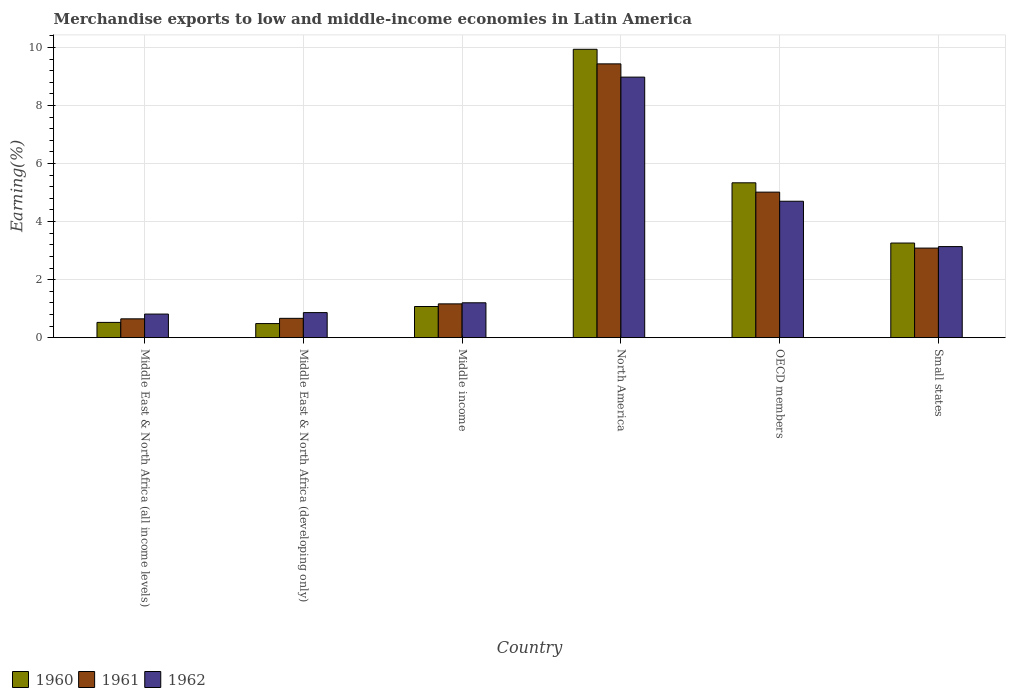How many groups of bars are there?
Your answer should be compact. 6. Are the number of bars per tick equal to the number of legend labels?
Ensure brevity in your answer.  Yes. What is the label of the 6th group of bars from the left?
Make the answer very short. Small states. In how many cases, is the number of bars for a given country not equal to the number of legend labels?
Your answer should be very brief. 0. What is the percentage of amount earned from merchandise exports in 1962 in Middle East & North Africa (all income levels)?
Make the answer very short. 0.81. Across all countries, what is the maximum percentage of amount earned from merchandise exports in 1960?
Offer a terse response. 9.94. Across all countries, what is the minimum percentage of amount earned from merchandise exports in 1961?
Ensure brevity in your answer.  0.65. In which country was the percentage of amount earned from merchandise exports in 1961 minimum?
Your answer should be very brief. Middle East & North Africa (all income levels). What is the total percentage of amount earned from merchandise exports in 1962 in the graph?
Make the answer very short. 19.7. What is the difference between the percentage of amount earned from merchandise exports in 1962 in Middle income and that in North America?
Provide a short and direct response. -7.78. What is the difference between the percentage of amount earned from merchandise exports in 1961 in North America and the percentage of amount earned from merchandise exports in 1962 in Middle East & North Africa (developing only)?
Provide a short and direct response. 8.57. What is the average percentage of amount earned from merchandise exports in 1961 per country?
Keep it short and to the point. 3.34. What is the difference between the percentage of amount earned from merchandise exports of/in 1961 and percentage of amount earned from merchandise exports of/in 1960 in Middle East & North Africa (all income levels)?
Make the answer very short. 0.12. What is the ratio of the percentage of amount earned from merchandise exports in 1960 in North America to that in OECD members?
Your answer should be compact. 1.86. Is the difference between the percentage of amount earned from merchandise exports in 1961 in Middle East & North Africa (all income levels) and Small states greater than the difference between the percentage of amount earned from merchandise exports in 1960 in Middle East & North Africa (all income levels) and Small states?
Your response must be concise. Yes. What is the difference between the highest and the second highest percentage of amount earned from merchandise exports in 1960?
Provide a short and direct response. 6.68. What is the difference between the highest and the lowest percentage of amount earned from merchandise exports in 1962?
Offer a very short reply. 8.17. In how many countries, is the percentage of amount earned from merchandise exports in 1960 greater than the average percentage of amount earned from merchandise exports in 1960 taken over all countries?
Ensure brevity in your answer.  2. Is the sum of the percentage of amount earned from merchandise exports in 1960 in North America and OECD members greater than the maximum percentage of amount earned from merchandise exports in 1961 across all countries?
Offer a terse response. Yes. Is it the case that in every country, the sum of the percentage of amount earned from merchandise exports in 1960 and percentage of amount earned from merchandise exports in 1961 is greater than the percentage of amount earned from merchandise exports in 1962?
Offer a terse response. Yes. How many bars are there?
Give a very brief answer. 18. How many countries are there in the graph?
Provide a short and direct response. 6. Does the graph contain any zero values?
Give a very brief answer. No. Does the graph contain grids?
Offer a terse response. Yes. Where does the legend appear in the graph?
Your answer should be compact. Bottom left. How many legend labels are there?
Ensure brevity in your answer.  3. What is the title of the graph?
Your response must be concise. Merchandise exports to low and middle-income economies in Latin America. What is the label or title of the X-axis?
Offer a very short reply. Country. What is the label or title of the Y-axis?
Provide a succinct answer. Earning(%). What is the Earning(%) in 1960 in Middle East & North Africa (all income levels)?
Offer a terse response. 0.53. What is the Earning(%) of 1961 in Middle East & North Africa (all income levels)?
Your response must be concise. 0.65. What is the Earning(%) of 1962 in Middle East & North Africa (all income levels)?
Your answer should be very brief. 0.81. What is the Earning(%) of 1960 in Middle East & North Africa (developing only)?
Your response must be concise. 0.49. What is the Earning(%) in 1961 in Middle East & North Africa (developing only)?
Your answer should be compact. 0.67. What is the Earning(%) in 1962 in Middle East & North Africa (developing only)?
Offer a terse response. 0.86. What is the Earning(%) of 1960 in Middle income?
Your answer should be compact. 1.07. What is the Earning(%) of 1961 in Middle income?
Make the answer very short. 1.16. What is the Earning(%) in 1962 in Middle income?
Your answer should be compact. 1.2. What is the Earning(%) of 1960 in North America?
Provide a short and direct response. 9.94. What is the Earning(%) of 1961 in North America?
Your answer should be very brief. 9.44. What is the Earning(%) in 1962 in North America?
Your answer should be very brief. 8.98. What is the Earning(%) of 1960 in OECD members?
Provide a succinct answer. 5.34. What is the Earning(%) of 1961 in OECD members?
Provide a succinct answer. 5.02. What is the Earning(%) of 1962 in OECD members?
Your answer should be compact. 4.7. What is the Earning(%) in 1960 in Small states?
Your answer should be compact. 3.26. What is the Earning(%) of 1961 in Small states?
Provide a short and direct response. 3.09. What is the Earning(%) in 1962 in Small states?
Your answer should be very brief. 3.14. Across all countries, what is the maximum Earning(%) in 1960?
Offer a very short reply. 9.94. Across all countries, what is the maximum Earning(%) of 1961?
Offer a terse response. 9.44. Across all countries, what is the maximum Earning(%) of 1962?
Your response must be concise. 8.98. Across all countries, what is the minimum Earning(%) in 1960?
Make the answer very short. 0.49. Across all countries, what is the minimum Earning(%) of 1961?
Your answer should be very brief. 0.65. Across all countries, what is the minimum Earning(%) in 1962?
Provide a short and direct response. 0.81. What is the total Earning(%) of 1960 in the graph?
Keep it short and to the point. 20.62. What is the total Earning(%) in 1961 in the graph?
Your answer should be compact. 20.02. What is the total Earning(%) of 1962 in the graph?
Your answer should be compact. 19.7. What is the difference between the Earning(%) of 1960 in Middle East & North Africa (all income levels) and that in Middle East & North Africa (developing only)?
Give a very brief answer. 0.04. What is the difference between the Earning(%) in 1961 in Middle East & North Africa (all income levels) and that in Middle East & North Africa (developing only)?
Your answer should be very brief. -0.02. What is the difference between the Earning(%) of 1962 in Middle East & North Africa (all income levels) and that in Middle East & North Africa (developing only)?
Offer a terse response. -0.05. What is the difference between the Earning(%) in 1960 in Middle East & North Africa (all income levels) and that in Middle income?
Provide a short and direct response. -0.55. What is the difference between the Earning(%) in 1961 in Middle East & North Africa (all income levels) and that in Middle income?
Ensure brevity in your answer.  -0.52. What is the difference between the Earning(%) of 1962 in Middle East & North Africa (all income levels) and that in Middle income?
Give a very brief answer. -0.39. What is the difference between the Earning(%) of 1960 in Middle East & North Africa (all income levels) and that in North America?
Your answer should be compact. -9.41. What is the difference between the Earning(%) of 1961 in Middle East & North Africa (all income levels) and that in North America?
Give a very brief answer. -8.79. What is the difference between the Earning(%) in 1962 in Middle East & North Africa (all income levels) and that in North America?
Provide a short and direct response. -8.17. What is the difference between the Earning(%) of 1960 in Middle East & North Africa (all income levels) and that in OECD members?
Provide a succinct answer. -4.81. What is the difference between the Earning(%) of 1961 in Middle East & North Africa (all income levels) and that in OECD members?
Offer a very short reply. -4.37. What is the difference between the Earning(%) of 1962 in Middle East & North Africa (all income levels) and that in OECD members?
Make the answer very short. -3.89. What is the difference between the Earning(%) in 1960 in Middle East & North Africa (all income levels) and that in Small states?
Your response must be concise. -2.73. What is the difference between the Earning(%) of 1961 in Middle East & North Africa (all income levels) and that in Small states?
Your answer should be compact. -2.44. What is the difference between the Earning(%) in 1962 in Middle East & North Africa (all income levels) and that in Small states?
Your answer should be compact. -2.33. What is the difference between the Earning(%) of 1960 in Middle East & North Africa (developing only) and that in Middle income?
Make the answer very short. -0.59. What is the difference between the Earning(%) of 1961 in Middle East & North Africa (developing only) and that in Middle income?
Offer a terse response. -0.5. What is the difference between the Earning(%) of 1962 in Middle East & North Africa (developing only) and that in Middle income?
Ensure brevity in your answer.  -0.34. What is the difference between the Earning(%) of 1960 in Middle East & North Africa (developing only) and that in North America?
Make the answer very short. -9.45. What is the difference between the Earning(%) in 1961 in Middle East & North Africa (developing only) and that in North America?
Provide a short and direct response. -8.77. What is the difference between the Earning(%) of 1962 in Middle East & North Africa (developing only) and that in North America?
Offer a very short reply. -8.12. What is the difference between the Earning(%) in 1960 in Middle East & North Africa (developing only) and that in OECD members?
Make the answer very short. -4.85. What is the difference between the Earning(%) of 1961 in Middle East & North Africa (developing only) and that in OECD members?
Make the answer very short. -4.35. What is the difference between the Earning(%) in 1962 in Middle East & North Africa (developing only) and that in OECD members?
Provide a short and direct response. -3.84. What is the difference between the Earning(%) of 1960 in Middle East & North Africa (developing only) and that in Small states?
Make the answer very short. -2.77. What is the difference between the Earning(%) of 1961 in Middle East & North Africa (developing only) and that in Small states?
Your answer should be compact. -2.42. What is the difference between the Earning(%) of 1962 in Middle East & North Africa (developing only) and that in Small states?
Your answer should be very brief. -2.28. What is the difference between the Earning(%) of 1960 in Middle income and that in North America?
Keep it short and to the point. -8.86. What is the difference between the Earning(%) of 1961 in Middle income and that in North America?
Ensure brevity in your answer.  -8.27. What is the difference between the Earning(%) of 1962 in Middle income and that in North America?
Give a very brief answer. -7.78. What is the difference between the Earning(%) in 1960 in Middle income and that in OECD members?
Offer a terse response. -4.26. What is the difference between the Earning(%) of 1961 in Middle income and that in OECD members?
Your answer should be very brief. -3.85. What is the difference between the Earning(%) in 1962 in Middle income and that in OECD members?
Offer a terse response. -3.5. What is the difference between the Earning(%) in 1960 in Middle income and that in Small states?
Offer a terse response. -2.19. What is the difference between the Earning(%) in 1961 in Middle income and that in Small states?
Make the answer very short. -1.92. What is the difference between the Earning(%) of 1962 in Middle income and that in Small states?
Keep it short and to the point. -1.94. What is the difference between the Earning(%) in 1960 in North America and that in OECD members?
Keep it short and to the point. 4.6. What is the difference between the Earning(%) in 1961 in North America and that in OECD members?
Offer a terse response. 4.42. What is the difference between the Earning(%) in 1962 in North America and that in OECD members?
Offer a terse response. 4.28. What is the difference between the Earning(%) in 1960 in North America and that in Small states?
Offer a terse response. 6.68. What is the difference between the Earning(%) of 1961 in North America and that in Small states?
Make the answer very short. 6.35. What is the difference between the Earning(%) of 1962 in North America and that in Small states?
Keep it short and to the point. 5.84. What is the difference between the Earning(%) of 1960 in OECD members and that in Small states?
Your response must be concise. 2.08. What is the difference between the Earning(%) in 1961 in OECD members and that in Small states?
Your answer should be very brief. 1.93. What is the difference between the Earning(%) in 1962 in OECD members and that in Small states?
Offer a terse response. 1.56. What is the difference between the Earning(%) in 1960 in Middle East & North Africa (all income levels) and the Earning(%) in 1961 in Middle East & North Africa (developing only)?
Keep it short and to the point. -0.14. What is the difference between the Earning(%) of 1960 in Middle East & North Africa (all income levels) and the Earning(%) of 1962 in Middle East & North Africa (developing only)?
Provide a short and direct response. -0.34. What is the difference between the Earning(%) of 1961 in Middle East & North Africa (all income levels) and the Earning(%) of 1962 in Middle East & North Africa (developing only)?
Your answer should be compact. -0.21. What is the difference between the Earning(%) of 1960 in Middle East & North Africa (all income levels) and the Earning(%) of 1961 in Middle income?
Ensure brevity in your answer.  -0.64. What is the difference between the Earning(%) of 1960 in Middle East & North Africa (all income levels) and the Earning(%) of 1962 in Middle income?
Your answer should be very brief. -0.68. What is the difference between the Earning(%) in 1961 in Middle East & North Africa (all income levels) and the Earning(%) in 1962 in Middle income?
Your answer should be compact. -0.55. What is the difference between the Earning(%) of 1960 in Middle East & North Africa (all income levels) and the Earning(%) of 1961 in North America?
Give a very brief answer. -8.91. What is the difference between the Earning(%) of 1960 in Middle East & North Africa (all income levels) and the Earning(%) of 1962 in North America?
Make the answer very short. -8.45. What is the difference between the Earning(%) of 1961 in Middle East & North Africa (all income levels) and the Earning(%) of 1962 in North America?
Give a very brief answer. -8.33. What is the difference between the Earning(%) of 1960 in Middle East & North Africa (all income levels) and the Earning(%) of 1961 in OECD members?
Your answer should be very brief. -4.49. What is the difference between the Earning(%) in 1960 in Middle East & North Africa (all income levels) and the Earning(%) in 1962 in OECD members?
Offer a very short reply. -4.18. What is the difference between the Earning(%) of 1961 in Middle East & North Africa (all income levels) and the Earning(%) of 1962 in OECD members?
Make the answer very short. -4.05. What is the difference between the Earning(%) in 1960 in Middle East & North Africa (all income levels) and the Earning(%) in 1961 in Small states?
Offer a terse response. -2.56. What is the difference between the Earning(%) in 1960 in Middle East & North Africa (all income levels) and the Earning(%) in 1962 in Small states?
Your response must be concise. -2.61. What is the difference between the Earning(%) in 1961 in Middle East & North Africa (all income levels) and the Earning(%) in 1962 in Small states?
Give a very brief answer. -2.49. What is the difference between the Earning(%) of 1960 in Middle East & North Africa (developing only) and the Earning(%) of 1961 in Middle income?
Provide a succinct answer. -0.68. What is the difference between the Earning(%) in 1960 in Middle East & North Africa (developing only) and the Earning(%) in 1962 in Middle income?
Ensure brevity in your answer.  -0.72. What is the difference between the Earning(%) of 1961 in Middle East & North Africa (developing only) and the Earning(%) of 1962 in Middle income?
Make the answer very short. -0.54. What is the difference between the Earning(%) in 1960 in Middle East & North Africa (developing only) and the Earning(%) in 1961 in North America?
Offer a very short reply. -8.95. What is the difference between the Earning(%) of 1960 in Middle East & North Africa (developing only) and the Earning(%) of 1962 in North America?
Keep it short and to the point. -8.49. What is the difference between the Earning(%) in 1961 in Middle East & North Africa (developing only) and the Earning(%) in 1962 in North America?
Your answer should be very brief. -8.31. What is the difference between the Earning(%) in 1960 in Middle East & North Africa (developing only) and the Earning(%) in 1961 in OECD members?
Provide a succinct answer. -4.53. What is the difference between the Earning(%) of 1960 in Middle East & North Africa (developing only) and the Earning(%) of 1962 in OECD members?
Keep it short and to the point. -4.22. What is the difference between the Earning(%) of 1961 in Middle East & North Africa (developing only) and the Earning(%) of 1962 in OECD members?
Provide a short and direct response. -4.04. What is the difference between the Earning(%) of 1960 in Middle East & North Africa (developing only) and the Earning(%) of 1961 in Small states?
Your answer should be very brief. -2.6. What is the difference between the Earning(%) in 1960 in Middle East & North Africa (developing only) and the Earning(%) in 1962 in Small states?
Your answer should be compact. -2.65. What is the difference between the Earning(%) of 1961 in Middle East & North Africa (developing only) and the Earning(%) of 1962 in Small states?
Make the answer very short. -2.47. What is the difference between the Earning(%) of 1960 in Middle income and the Earning(%) of 1961 in North America?
Offer a terse response. -8.36. What is the difference between the Earning(%) in 1960 in Middle income and the Earning(%) in 1962 in North America?
Offer a very short reply. -7.91. What is the difference between the Earning(%) in 1961 in Middle income and the Earning(%) in 1962 in North America?
Your answer should be very brief. -7.81. What is the difference between the Earning(%) in 1960 in Middle income and the Earning(%) in 1961 in OECD members?
Keep it short and to the point. -3.94. What is the difference between the Earning(%) in 1960 in Middle income and the Earning(%) in 1962 in OECD members?
Your answer should be very brief. -3.63. What is the difference between the Earning(%) in 1961 in Middle income and the Earning(%) in 1962 in OECD members?
Provide a succinct answer. -3.54. What is the difference between the Earning(%) of 1960 in Middle income and the Earning(%) of 1961 in Small states?
Offer a very short reply. -2.01. What is the difference between the Earning(%) of 1960 in Middle income and the Earning(%) of 1962 in Small states?
Provide a succinct answer. -2.06. What is the difference between the Earning(%) in 1961 in Middle income and the Earning(%) in 1962 in Small states?
Provide a short and direct response. -1.97. What is the difference between the Earning(%) in 1960 in North America and the Earning(%) in 1961 in OECD members?
Make the answer very short. 4.92. What is the difference between the Earning(%) of 1960 in North America and the Earning(%) of 1962 in OECD members?
Offer a very short reply. 5.24. What is the difference between the Earning(%) in 1961 in North America and the Earning(%) in 1962 in OECD members?
Your answer should be compact. 4.73. What is the difference between the Earning(%) of 1960 in North America and the Earning(%) of 1961 in Small states?
Your answer should be compact. 6.85. What is the difference between the Earning(%) of 1960 in North America and the Earning(%) of 1962 in Small states?
Your answer should be very brief. 6.8. What is the difference between the Earning(%) in 1961 in North America and the Earning(%) in 1962 in Small states?
Your response must be concise. 6.3. What is the difference between the Earning(%) in 1960 in OECD members and the Earning(%) in 1961 in Small states?
Give a very brief answer. 2.25. What is the difference between the Earning(%) of 1960 in OECD members and the Earning(%) of 1962 in Small states?
Ensure brevity in your answer.  2.2. What is the difference between the Earning(%) of 1961 in OECD members and the Earning(%) of 1962 in Small states?
Give a very brief answer. 1.88. What is the average Earning(%) in 1960 per country?
Make the answer very short. 3.44. What is the average Earning(%) in 1961 per country?
Give a very brief answer. 3.34. What is the average Earning(%) of 1962 per country?
Ensure brevity in your answer.  3.28. What is the difference between the Earning(%) in 1960 and Earning(%) in 1961 in Middle East & North Africa (all income levels)?
Make the answer very short. -0.12. What is the difference between the Earning(%) in 1960 and Earning(%) in 1962 in Middle East & North Africa (all income levels)?
Ensure brevity in your answer.  -0.29. What is the difference between the Earning(%) of 1961 and Earning(%) of 1962 in Middle East & North Africa (all income levels)?
Keep it short and to the point. -0.16. What is the difference between the Earning(%) in 1960 and Earning(%) in 1961 in Middle East & North Africa (developing only)?
Your answer should be compact. -0.18. What is the difference between the Earning(%) of 1960 and Earning(%) of 1962 in Middle East & North Africa (developing only)?
Your answer should be compact. -0.38. What is the difference between the Earning(%) of 1961 and Earning(%) of 1962 in Middle East & North Africa (developing only)?
Offer a terse response. -0.2. What is the difference between the Earning(%) in 1960 and Earning(%) in 1961 in Middle income?
Offer a very short reply. -0.09. What is the difference between the Earning(%) of 1960 and Earning(%) of 1962 in Middle income?
Provide a succinct answer. -0.13. What is the difference between the Earning(%) of 1961 and Earning(%) of 1962 in Middle income?
Offer a very short reply. -0.04. What is the difference between the Earning(%) of 1960 and Earning(%) of 1961 in North America?
Offer a very short reply. 0.5. What is the difference between the Earning(%) of 1960 and Earning(%) of 1962 in North America?
Provide a succinct answer. 0.96. What is the difference between the Earning(%) in 1961 and Earning(%) in 1962 in North America?
Give a very brief answer. 0.46. What is the difference between the Earning(%) in 1960 and Earning(%) in 1961 in OECD members?
Your response must be concise. 0.32. What is the difference between the Earning(%) in 1960 and Earning(%) in 1962 in OECD members?
Provide a succinct answer. 0.64. What is the difference between the Earning(%) of 1961 and Earning(%) of 1962 in OECD members?
Your answer should be compact. 0.31. What is the difference between the Earning(%) of 1960 and Earning(%) of 1961 in Small states?
Make the answer very short. 0.17. What is the difference between the Earning(%) in 1960 and Earning(%) in 1962 in Small states?
Offer a terse response. 0.12. What is the difference between the Earning(%) in 1961 and Earning(%) in 1962 in Small states?
Keep it short and to the point. -0.05. What is the ratio of the Earning(%) in 1960 in Middle East & North Africa (all income levels) to that in Middle East & North Africa (developing only)?
Offer a terse response. 1.08. What is the ratio of the Earning(%) in 1961 in Middle East & North Africa (all income levels) to that in Middle East & North Africa (developing only)?
Give a very brief answer. 0.97. What is the ratio of the Earning(%) in 1962 in Middle East & North Africa (all income levels) to that in Middle East & North Africa (developing only)?
Offer a very short reply. 0.94. What is the ratio of the Earning(%) of 1960 in Middle East & North Africa (all income levels) to that in Middle income?
Your answer should be compact. 0.49. What is the ratio of the Earning(%) in 1961 in Middle East & North Africa (all income levels) to that in Middle income?
Make the answer very short. 0.56. What is the ratio of the Earning(%) of 1962 in Middle East & North Africa (all income levels) to that in Middle income?
Provide a succinct answer. 0.68. What is the ratio of the Earning(%) in 1960 in Middle East & North Africa (all income levels) to that in North America?
Provide a short and direct response. 0.05. What is the ratio of the Earning(%) of 1961 in Middle East & North Africa (all income levels) to that in North America?
Make the answer very short. 0.07. What is the ratio of the Earning(%) of 1962 in Middle East & North Africa (all income levels) to that in North America?
Your response must be concise. 0.09. What is the ratio of the Earning(%) of 1960 in Middle East & North Africa (all income levels) to that in OECD members?
Your response must be concise. 0.1. What is the ratio of the Earning(%) of 1961 in Middle East & North Africa (all income levels) to that in OECD members?
Offer a very short reply. 0.13. What is the ratio of the Earning(%) in 1962 in Middle East & North Africa (all income levels) to that in OECD members?
Keep it short and to the point. 0.17. What is the ratio of the Earning(%) of 1960 in Middle East & North Africa (all income levels) to that in Small states?
Your answer should be very brief. 0.16. What is the ratio of the Earning(%) of 1961 in Middle East & North Africa (all income levels) to that in Small states?
Your answer should be compact. 0.21. What is the ratio of the Earning(%) of 1962 in Middle East & North Africa (all income levels) to that in Small states?
Your response must be concise. 0.26. What is the ratio of the Earning(%) in 1960 in Middle East & North Africa (developing only) to that in Middle income?
Keep it short and to the point. 0.45. What is the ratio of the Earning(%) in 1961 in Middle East & North Africa (developing only) to that in Middle income?
Your answer should be compact. 0.57. What is the ratio of the Earning(%) of 1962 in Middle East & North Africa (developing only) to that in Middle income?
Provide a short and direct response. 0.72. What is the ratio of the Earning(%) in 1960 in Middle East & North Africa (developing only) to that in North America?
Provide a succinct answer. 0.05. What is the ratio of the Earning(%) in 1961 in Middle East & North Africa (developing only) to that in North America?
Offer a very short reply. 0.07. What is the ratio of the Earning(%) in 1962 in Middle East & North Africa (developing only) to that in North America?
Offer a terse response. 0.1. What is the ratio of the Earning(%) of 1960 in Middle East & North Africa (developing only) to that in OECD members?
Offer a very short reply. 0.09. What is the ratio of the Earning(%) of 1961 in Middle East & North Africa (developing only) to that in OECD members?
Keep it short and to the point. 0.13. What is the ratio of the Earning(%) in 1962 in Middle East & North Africa (developing only) to that in OECD members?
Your answer should be very brief. 0.18. What is the ratio of the Earning(%) in 1960 in Middle East & North Africa (developing only) to that in Small states?
Offer a terse response. 0.15. What is the ratio of the Earning(%) of 1961 in Middle East & North Africa (developing only) to that in Small states?
Provide a short and direct response. 0.22. What is the ratio of the Earning(%) in 1962 in Middle East & North Africa (developing only) to that in Small states?
Provide a succinct answer. 0.28. What is the ratio of the Earning(%) in 1960 in Middle income to that in North America?
Ensure brevity in your answer.  0.11. What is the ratio of the Earning(%) of 1961 in Middle income to that in North America?
Your answer should be compact. 0.12. What is the ratio of the Earning(%) of 1962 in Middle income to that in North America?
Provide a short and direct response. 0.13. What is the ratio of the Earning(%) in 1960 in Middle income to that in OECD members?
Ensure brevity in your answer.  0.2. What is the ratio of the Earning(%) of 1961 in Middle income to that in OECD members?
Your response must be concise. 0.23. What is the ratio of the Earning(%) in 1962 in Middle income to that in OECD members?
Your answer should be very brief. 0.26. What is the ratio of the Earning(%) of 1960 in Middle income to that in Small states?
Provide a short and direct response. 0.33. What is the ratio of the Earning(%) in 1961 in Middle income to that in Small states?
Your response must be concise. 0.38. What is the ratio of the Earning(%) of 1962 in Middle income to that in Small states?
Ensure brevity in your answer.  0.38. What is the ratio of the Earning(%) in 1960 in North America to that in OECD members?
Provide a short and direct response. 1.86. What is the ratio of the Earning(%) of 1961 in North America to that in OECD members?
Provide a succinct answer. 1.88. What is the ratio of the Earning(%) in 1962 in North America to that in OECD members?
Ensure brevity in your answer.  1.91. What is the ratio of the Earning(%) in 1960 in North America to that in Small states?
Make the answer very short. 3.05. What is the ratio of the Earning(%) of 1961 in North America to that in Small states?
Your answer should be very brief. 3.06. What is the ratio of the Earning(%) in 1962 in North America to that in Small states?
Make the answer very short. 2.86. What is the ratio of the Earning(%) in 1960 in OECD members to that in Small states?
Your answer should be compact. 1.64. What is the ratio of the Earning(%) of 1961 in OECD members to that in Small states?
Your answer should be very brief. 1.62. What is the ratio of the Earning(%) in 1962 in OECD members to that in Small states?
Your response must be concise. 1.5. What is the difference between the highest and the second highest Earning(%) of 1960?
Provide a short and direct response. 4.6. What is the difference between the highest and the second highest Earning(%) of 1961?
Provide a short and direct response. 4.42. What is the difference between the highest and the second highest Earning(%) in 1962?
Your answer should be compact. 4.28. What is the difference between the highest and the lowest Earning(%) in 1960?
Keep it short and to the point. 9.45. What is the difference between the highest and the lowest Earning(%) in 1961?
Make the answer very short. 8.79. What is the difference between the highest and the lowest Earning(%) of 1962?
Give a very brief answer. 8.17. 